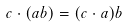Convert formula to latex. <formula><loc_0><loc_0><loc_500><loc_500>c \cdot ( a b ) = ( c \cdot a ) b</formula> 